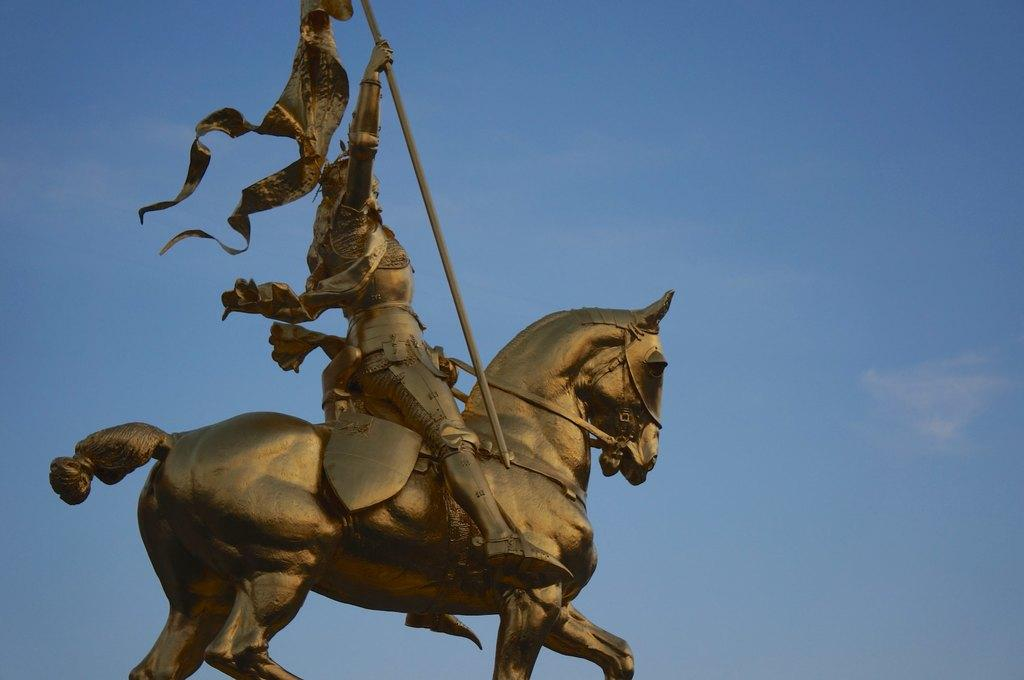What is the main subject of the image? There is a statue of a man and a horse in the image. What can be seen in the background of the image? The sky is visible in the background of the image. What type of trouble is the man on the horse experiencing in the image? There is no indication of trouble in the image; it simply depicts a statue of a man and a horse. Can you see a chessboard in the image? There is no chessboard present in the image. 